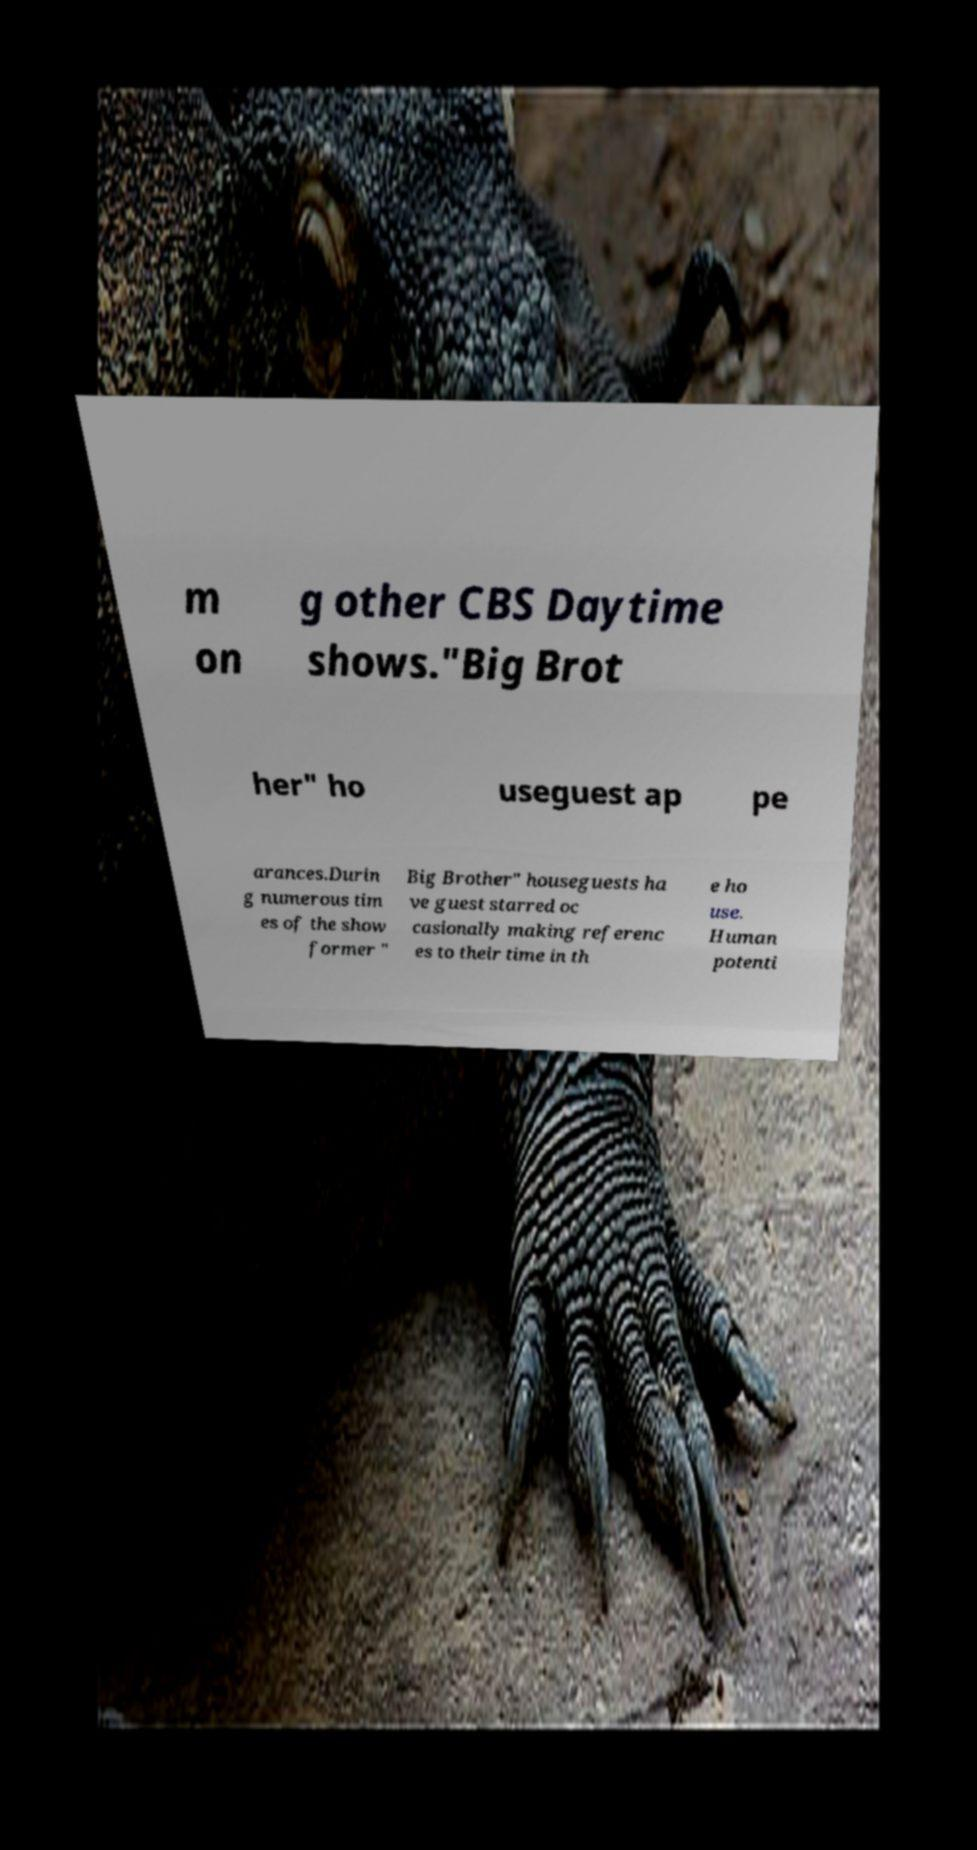Could you assist in decoding the text presented in this image and type it out clearly? m on g other CBS Daytime shows."Big Brot her" ho useguest ap pe arances.Durin g numerous tim es of the show former " Big Brother" houseguests ha ve guest starred oc casionally making referenc es to their time in th e ho use. Human potenti 